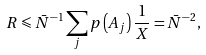Convert formula to latex. <formula><loc_0><loc_0><loc_500><loc_500>R \leqslant \bar { N } ^ { - 1 } \sum _ { j } p \left ( A _ { j } \right ) \frac { 1 } { X } = \bar { N } ^ { - 2 } ,</formula> 